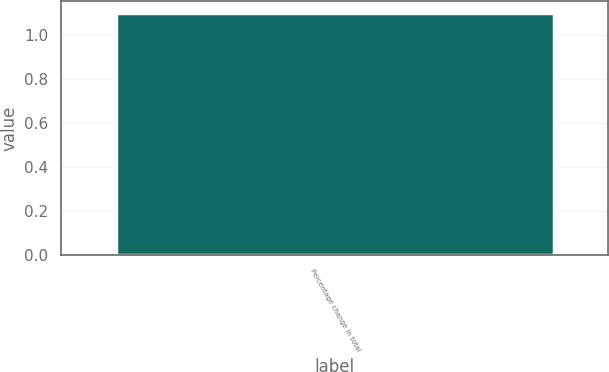Convert chart to OTSL. <chart><loc_0><loc_0><loc_500><loc_500><bar_chart><fcel>Percentage change in total<nl><fcel>1.1<nl></chart> 